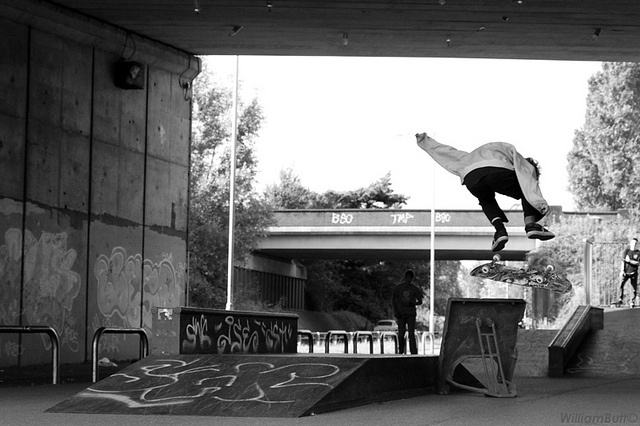Describe the objects in this image and their specific colors. I can see people in black, darkgray, gray, and lightgray tones, skateboard in black, gray, darkgray, and lightgray tones, people in black, gray, and lightgray tones, people in black, lightgray, darkgray, and gray tones, and car in black, gray, and lightgray tones in this image. 